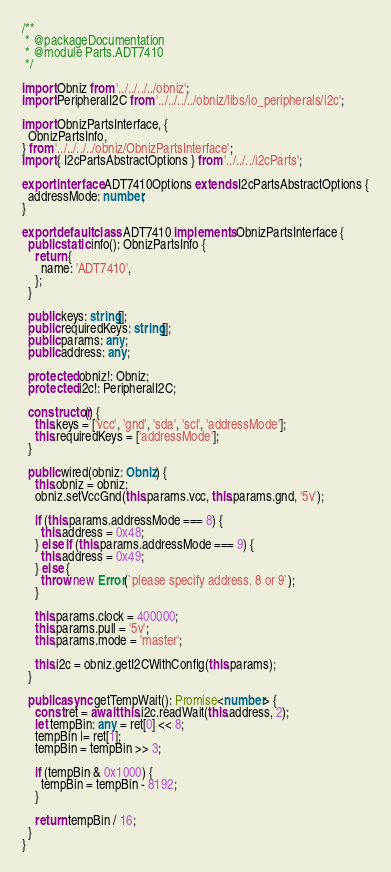Convert code to text. <code><loc_0><loc_0><loc_500><loc_500><_TypeScript_>/**
 * @packageDocumentation
 * @module Parts.ADT7410
 */

import Obniz from '../../../../obniz';
import PeripheralI2C from '../../../../obniz/libs/io_peripherals/i2c';

import ObnizPartsInterface, {
  ObnizPartsInfo,
} from '../../../../obniz/ObnizPartsInterface';
import { I2cPartsAbstractOptions } from '../../../i2cParts';

export interface ADT7410Options extends I2cPartsAbstractOptions {
  addressMode: number;
}

export default class ADT7410 implements ObnizPartsInterface {
  public static info(): ObnizPartsInfo {
    return {
      name: 'ADT7410',
    };
  }

  public keys: string[];
  public requiredKeys: string[];
  public params: any;
  public address: any;

  protected obniz!: Obniz;
  protected i2c!: PeripheralI2C;

  constructor() {
    this.keys = ['vcc', 'gnd', 'sda', 'scl', 'addressMode'];
    this.requiredKeys = ['addressMode'];
  }

  public wired(obniz: Obniz) {
    this.obniz = obniz;
    obniz.setVccGnd(this.params.vcc, this.params.gnd, '5v');

    if (this.params.addressMode === 8) {
      this.address = 0x48;
    } else if (this.params.addressMode === 9) {
      this.address = 0x49;
    } else {
      throw new Error(`please specify address. 8 or 9`);
    }

    this.params.clock = 400000;
    this.params.pull = '5v';
    this.params.mode = 'master';

    this.i2c = obniz.getI2CWithConfig(this.params);
  }

  public async getTempWait(): Promise<number> {
    const ret = await this.i2c.readWait(this.address, 2);
    let tempBin: any = ret[0] << 8;
    tempBin |= ret[1];
    tempBin = tempBin >> 3;

    if (tempBin & 0x1000) {
      tempBin = tempBin - 8192;
    }

    return tempBin / 16;
  }
}
</code> 